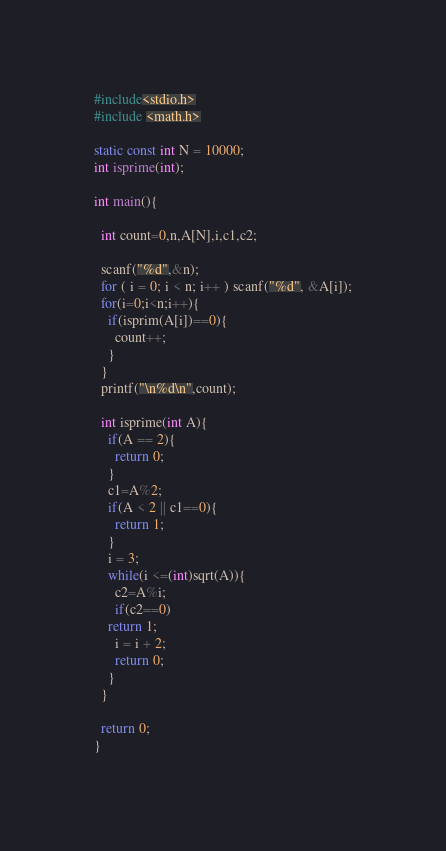<code> <loc_0><loc_0><loc_500><loc_500><_C_>#include<stdio.h>
#include <math.h>

static const int N = 10000;
int isprime(int);

int main(){
  
  int count=0,n,A[N],i,c1,c2;
  
  scanf("%d",&n);
  for ( i = 0; i < n; i++ ) scanf("%d", &A[i]);
  for(i=0;i<n;i++){
    if(isprim(A[i])==0){
      count++;
    }
  }
  printf("\n%d\n",count);
  
  int isprime(int A){
    if(A == 2){ 
      return 0;
    }
    c1=A%2;
    if(A < 2 || c1==0){
      return 1;
    }
    i = 3;
    while(i <=(int)sqrt(A)){
      c2=A%i;
      if(c2==0)
	return 1;
      i = i + 2;
      return 0;
    }
  }
  
  return 0;
}</code> 